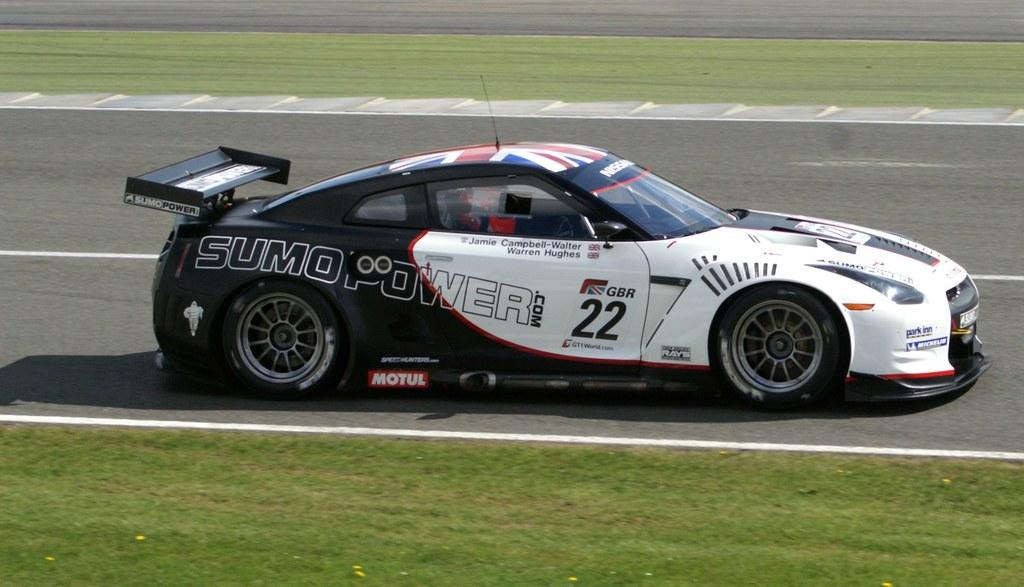What is the main subject of the image? The main subject of the image is a car. Where is the car located in the image? The car is on the road in the image. What type of vegetation can be seen on the ground in the image? There is grass visible on the ground in the image. What type of crate can be seen in the image? There is no crate present in the image. What type of stretch can be seen in the image? There is no stretch present in the image. What type of wine can be seen in the image? There is no wine present in the image. 